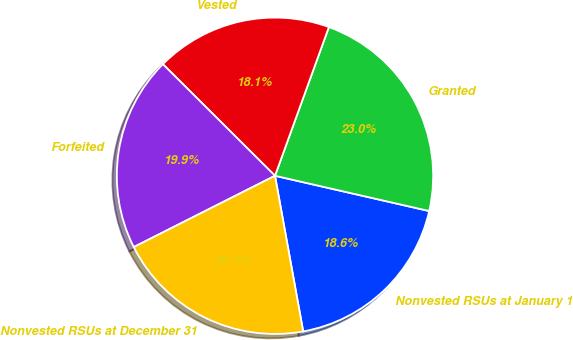<chart> <loc_0><loc_0><loc_500><loc_500><pie_chart><fcel>Nonvested RSUs at January 1<fcel>Granted<fcel>Vested<fcel>Forfeited<fcel>Nonvested RSUs at December 31<nl><fcel>18.57%<fcel>23.05%<fcel>18.07%<fcel>19.91%<fcel>20.41%<nl></chart> 